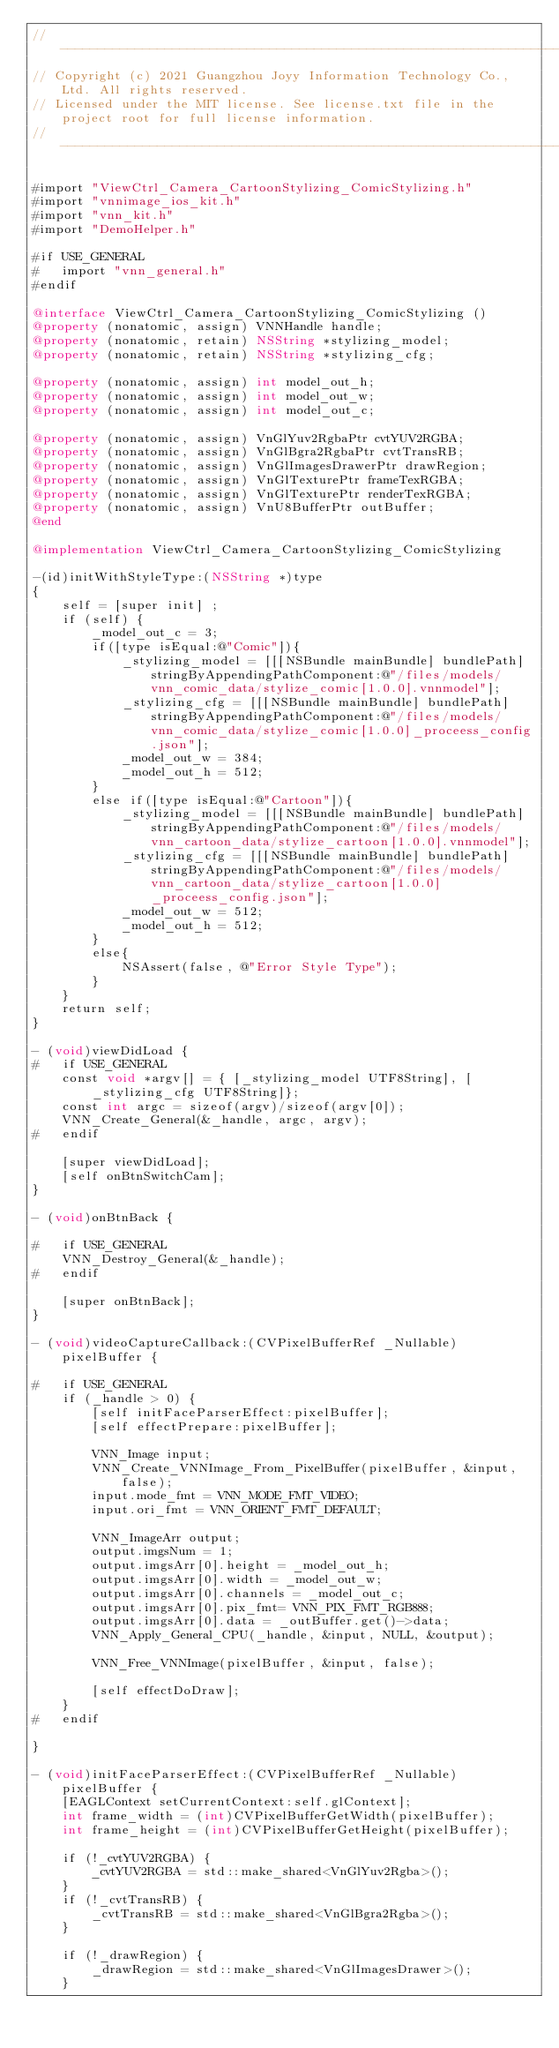<code> <loc_0><loc_0><loc_500><loc_500><_ObjectiveC_>//-------------------------------------------------------------------------------------------------------
// Copyright (c) 2021 Guangzhou Joyy Information Technology Co., Ltd. All rights reserved.
// Licensed under the MIT license. See license.txt file in the project root for full license information.
//-------------------------------------------------------------------------------------------------------

#import "ViewCtrl_Camera_CartoonStylizing_ComicStylizing.h"
#import "vnnimage_ios_kit.h"
#import "vnn_kit.h"
#import "DemoHelper.h"

#if USE_GENERAL
#   import "vnn_general.h"
#endif

@interface ViewCtrl_Camera_CartoonStylizing_ComicStylizing ()
@property (nonatomic, assign) VNNHandle handle;
@property (nonatomic, retain) NSString *stylizing_model;
@property (nonatomic, retain) NSString *stylizing_cfg;

@property (nonatomic, assign) int model_out_h;
@property (nonatomic, assign) int model_out_w;
@property (nonatomic, assign) int model_out_c;

@property (nonatomic, assign) VnGlYuv2RgbaPtr cvtYUV2RGBA;
@property (nonatomic, assign) VnGlBgra2RgbaPtr cvtTransRB;
@property (nonatomic, assign) VnGlImagesDrawerPtr drawRegion;
@property (nonatomic, assign) VnGlTexturePtr frameTexRGBA;
@property (nonatomic, assign) VnGlTexturePtr renderTexRGBA;
@property (nonatomic, assign) VnU8BufferPtr outBuffer;
@end

@implementation ViewCtrl_Camera_CartoonStylizing_ComicStylizing

-(id)initWithStyleType:(NSString *)type
{
    self = [super init] ;
    if (self) {
        _model_out_c = 3;
        if([type isEqual:@"Comic"]){
            _stylizing_model = [[[NSBundle mainBundle] bundlePath] stringByAppendingPathComponent:@"/files/models/vnn_comic_data/stylize_comic[1.0.0].vnnmodel"];
            _stylizing_cfg = [[[NSBundle mainBundle] bundlePath] stringByAppendingPathComponent:@"/files/models/vnn_comic_data/stylize_comic[1.0.0]_proceess_config.json"];
            _model_out_w = 384;
            _model_out_h = 512;
        }
        else if([type isEqual:@"Cartoon"]){
            _stylizing_model = [[[NSBundle mainBundle] bundlePath] stringByAppendingPathComponent:@"/files/models/vnn_cartoon_data/stylize_cartoon[1.0.0].vnnmodel"];
            _stylizing_cfg = [[[NSBundle mainBundle] bundlePath] stringByAppendingPathComponent:@"/files/models/vnn_cartoon_data/stylize_cartoon[1.0.0]_proceess_config.json"];
            _model_out_w = 512;
            _model_out_h = 512;
        }
        else{
            NSAssert(false, @"Error Style Type");
        }
    }
    return self;
}

- (void)viewDidLoad {
#   if USE_GENERAL
    const void *argv[] = { [_stylizing_model UTF8String], [_stylizing_cfg UTF8String]};
    const int argc = sizeof(argv)/sizeof(argv[0]);
    VNN_Create_General(&_handle, argc, argv);
#   endif
    
    [super viewDidLoad];
    [self onBtnSwitchCam];
}

- (void)onBtnBack {
    
#   if USE_GENERAL
    VNN_Destroy_General(&_handle);
#   endif
    
    [super onBtnBack];
}

- (void)videoCaptureCallback:(CVPixelBufferRef _Nullable)pixelBuffer {
    
#   if USE_GENERAL
    if (_handle > 0) {
        [self initFaceParserEffect:pixelBuffer];
        [self effectPrepare:pixelBuffer];
        
        VNN_Image input;
        VNN_Create_VNNImage_From_PixelBuffer(pixelBuffer, &input, false);
        input.mode_fmt = VNN_MODE_FMT_VIDEO;
        input.ori_fmt = VNN_ORIENT_FMT_DEFAULT;
        
        VNN_ImageArr output;
        output.imgsNum = 1;
        output.imgsArr[0].height = _model_out_h;
        output.imgsArr[0].width = _model_out_w;
        output.imgsArr[0].channels = _model_out_c;
        output.imgsArr[0].pix_fmt= VNN_PIX_FMT_RGB888;
        output.imgsArr[0].data = _outBuffer.get()->data;
        VNN_Apply_General_CPU(_handle, &input, NULL, &output);
        
        VNN_Free_VNNImage(pixelBuffer, &input, false);
        
        [self effectDoDraw];
    }
#   endif
    
}

- (void)initFaceParserEffect:(CVPixelBufferRef _Nullable)pixelBuffer {
    [EAGLContext setCurrentContext:self.glContext];
    int frame_width = (int)CVPixelBufferGetWidth(pixelBuffer);
    int frame_height = (int)CVPixelBufferGetHeight(pixelBuffer);
    
    if (!_cvtYUV2RGBA) {
        _cvtYUV2RGBA = std::make_shared<VnGlYuv2Rgba>();
    }
    if (!_cvtTransRB) {
        _cvtTransRB = std::make_shared<VnGlBgra2Rgba>();
    }
    
    if (!_drawRegion) {
        _drawRegion = std::make_shared<VnGlImagesDrawer>();
    }
    </code> 